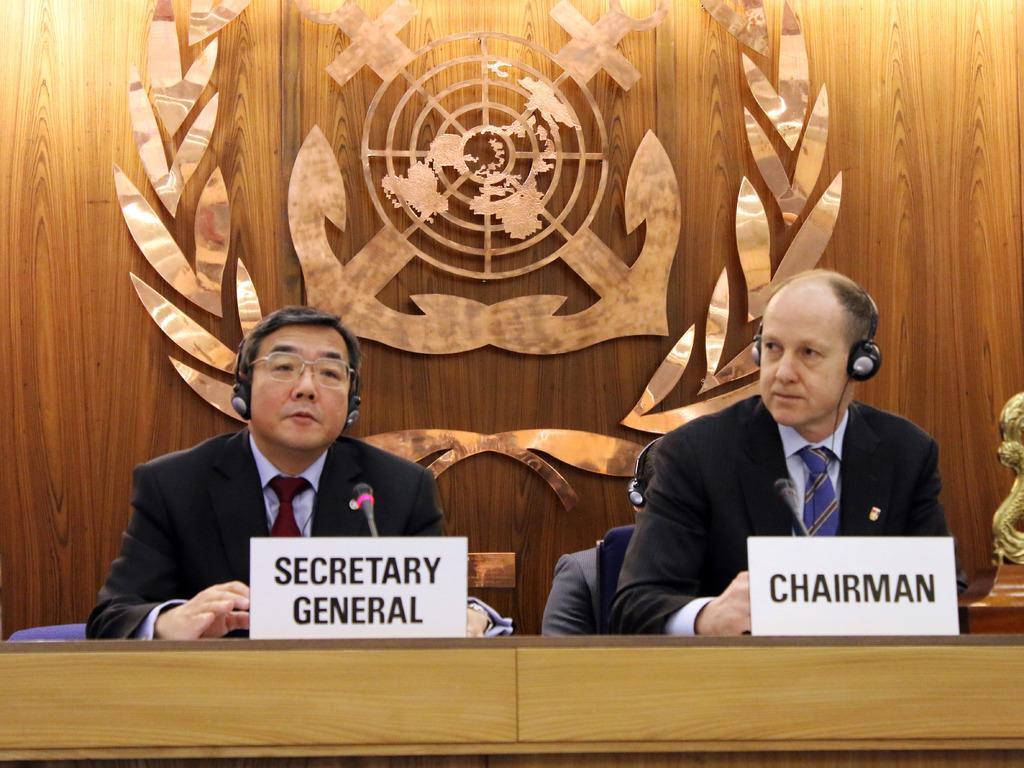In one or two sentences, can you explain what this image depicts? In this image there are two men who are sitting in the middle. In front of them there is a table on which there are two name boards. In the background there is a wooden wall on which there is a symbol. In front of them there are mics. They are wearing the headphones. Behind them there are two other persons sitting on the chairs. 